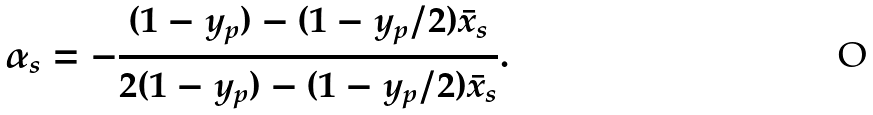Convert formula to latex. <formula><loc_0><loc_0><loc_500><loc_500>\alpha _ { s } = - \frac { ( 1 - y _ { p } ) - ( 1 - y _ { p } / 2 ) \bar { x } _ { s } } { 2 ( 1 - y _ { p } ) - ( 1 - y _ { p } / 2 ) \bar { x } _ { s } } .</formula> 